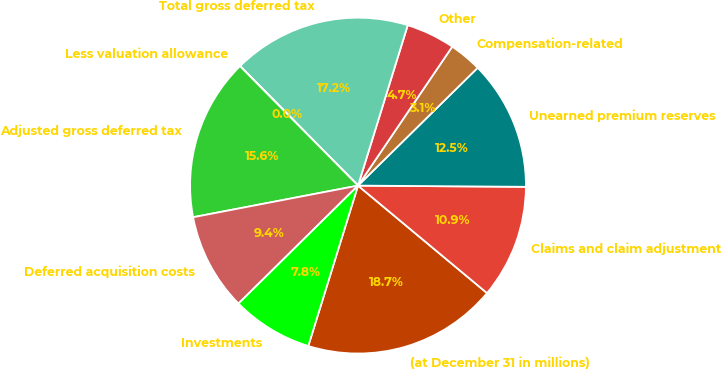<chart> <loc_0><loc_0><loc_500><loc_500><pie_chart><fcel>(at December 31 in millions)<fcel>Claims and claim adjustment<fcel>Unearned premium reserves<fcel>Compensation-related<fcel>Other<fcel>Total gross deferred tax<fcel>Less valuation allowance<fcel>Adjusted gross deferred tax<fcel>Deferred acquisition costs<fcel>Investments<nl><fcel>18.73%<fcel>10.94%<fcel>12.49%<fcel>3.14%<fcel>4.7%<fcel>17.17%<fcel>0.02%<fcel>15.61%<fcel>9.38%<fcel>7.82%<nl></chart> 